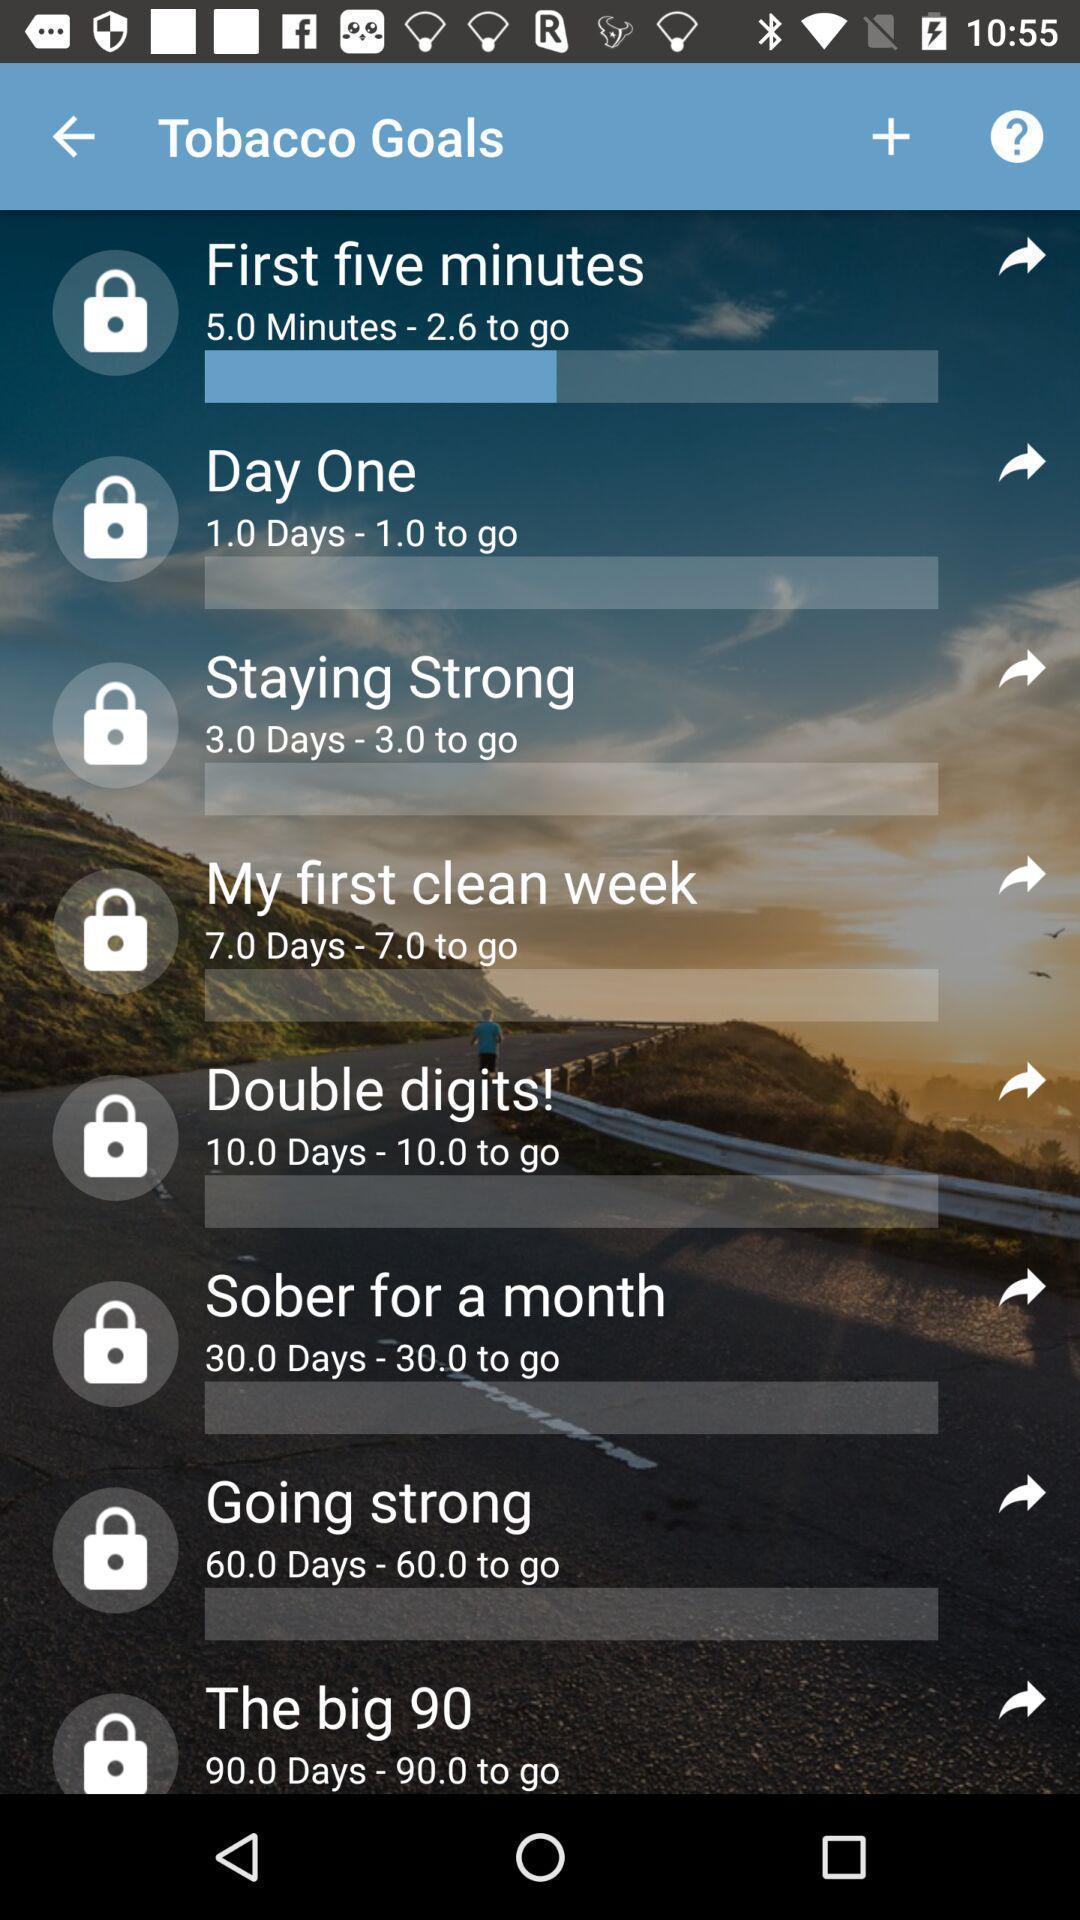Summarize the information in this screenshot. Screen displaying the list of tobacco goals. 